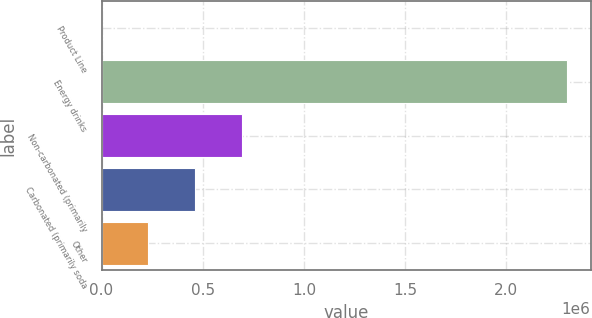Convert chart. <chart><loc_0><loc_0><loc_500><loc_500><bar_chart><fcel>Product Line<fcel>Energy drinks<fcel>Non-carbonated (primarily<fcel>Carbonated (primarily soda<fcel>Other<nl><fcel>2014<fcel>2.30222e+06<fcel>692077<fcel>462056<fcel>232035<nl></chart> 